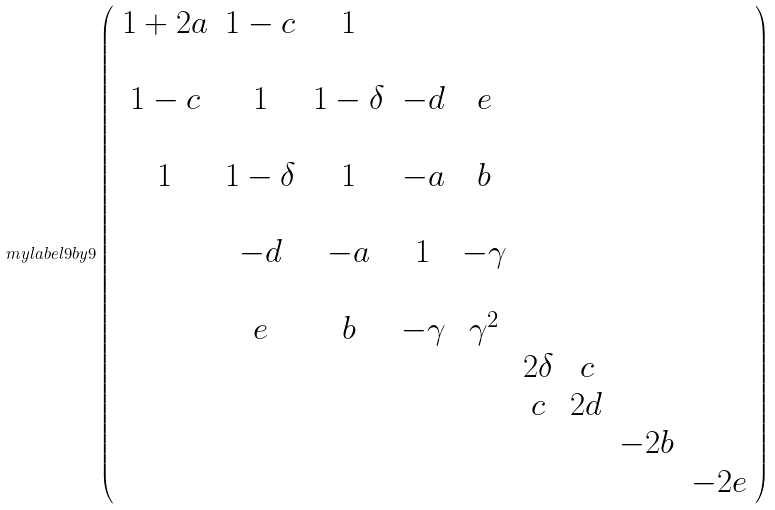Convert formula to latex. <formula><loc_0><loc_0><loc_500><loc_500>\ m y l a b e l { 9 b y 9 } \left ( \begin{array} { c c c c c c c c c } 1 + 2 a & 1 - c & 1 & & & & & & \\ \\ 1 - c & 1 & 1 - \delta & - d & e & & & & \\ \\ 1 & 1 - \delta & 1 & - a & b & & & & \\ \\ & - d & - a & 1 & - \gamma & & & & \\ \\ & e & b & - \gamma & \gamma ^ { 2 } & & & & \\ & & & & & 2 \delta & c & & \\ & & & & & c & 2 d & & \\ & & & & & & & - 2 b & \\ & & & & & & & & - 2 e \end{array} \right )</formula> 